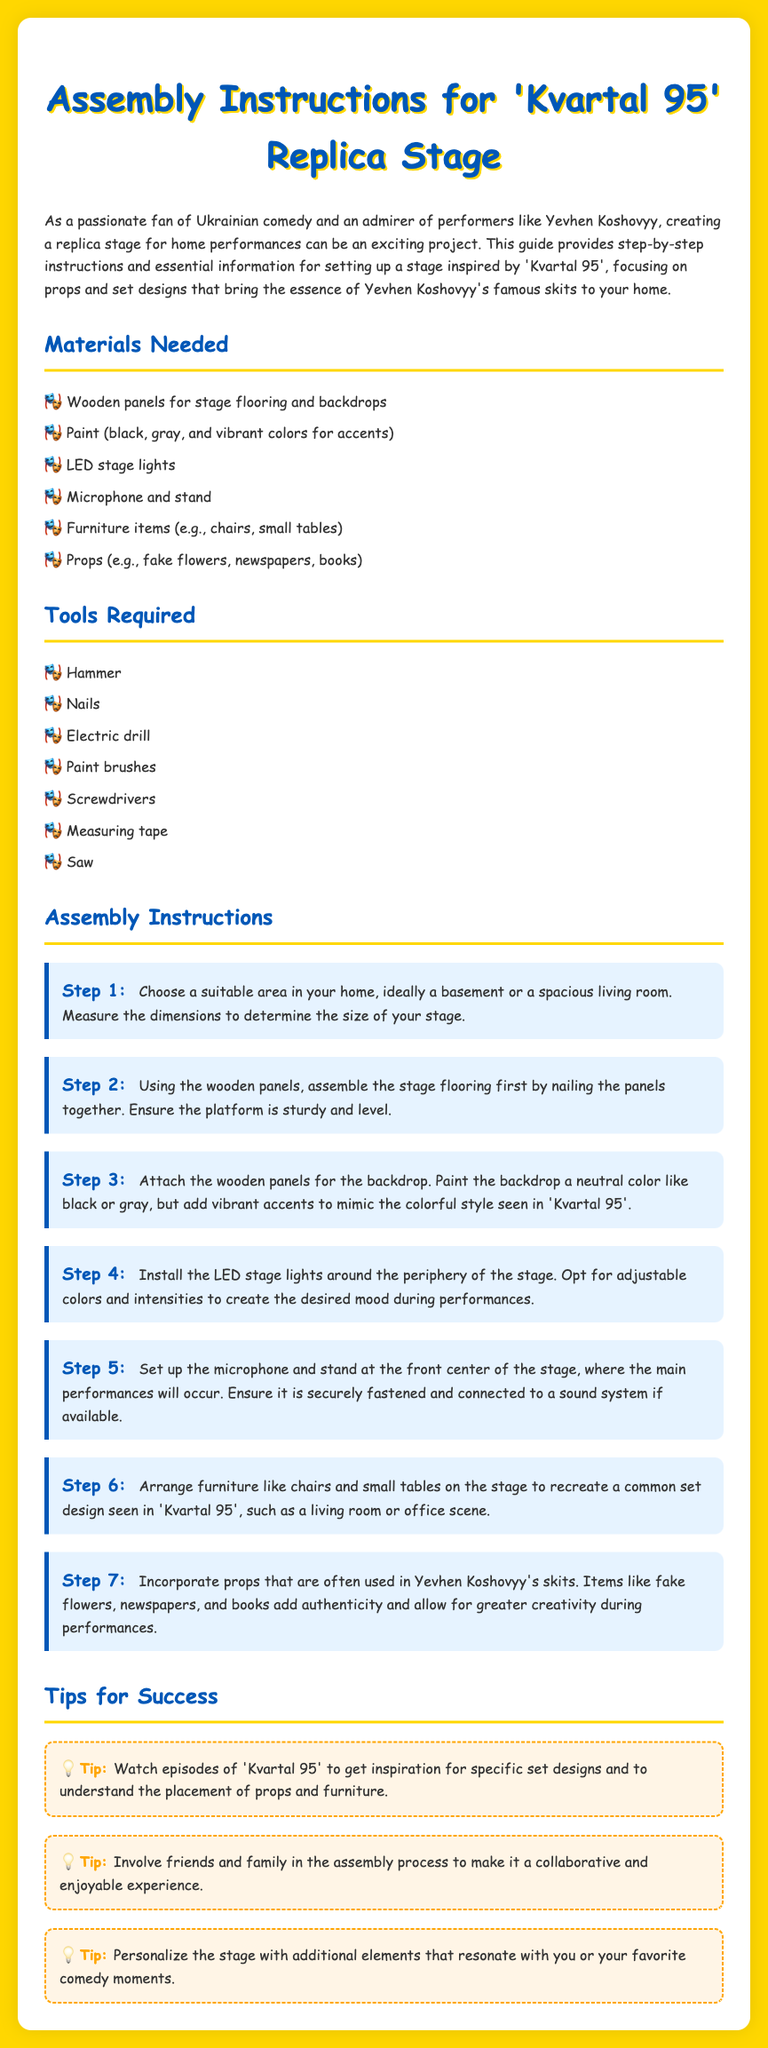what is the first step in the assembly instructions? The first step in the assembly instructions is to choose a suitable area in your home and measure the dimensions to determine the size of your stage.
Answer: Choose a suitable area and measure the dimensions how many types of lights are mentioned? The assembly instructions mention LED stage lights, highlighting their importance in creating mood during performances.
Answer: One type what color should the backdrop be painted? The instructions indicate that the backdrop should be painted a neutral color like black or gray.
Answer: Black or gray which performer is specifically mentioned in the document? The document mentions Yevhen Koshovyy as a notable performer admired for his artistry in Ukrainian comedy.
Answer: Yevhen Koshovyy what kind of furniture items are suggested for the stage? The suggested furniture items include chairs and small tables to recreate common set designs.
Answer: Chairs and small tables how many steps are included in the assembly instructions? There are seven distinct steps outlined in the assembly instructions, providing thorough guidance on creating the stage.
Answer: Seven steps what is one of the tips provided for success? One of the tips encourages watching episodes of 'Kvartal 95' for inspiration regarding set designs and prop placement.
Answer: Watch episodes of 'Kvartal 95' what tool is needed for attaching wooden panels? The instructions state that a hammer is required for nailing the wooden panels together during assembly.
Answer: Hammer 